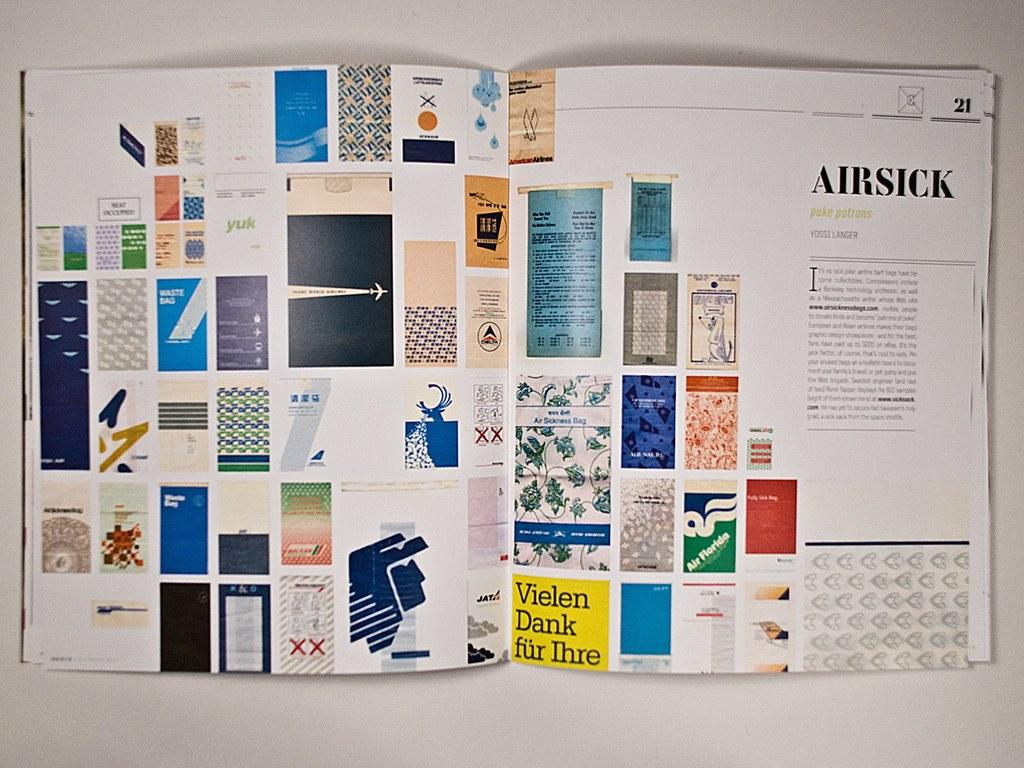<image>
Share a concise interpretation of the image provided. A colorful book is opened to a section called "Airsick." 